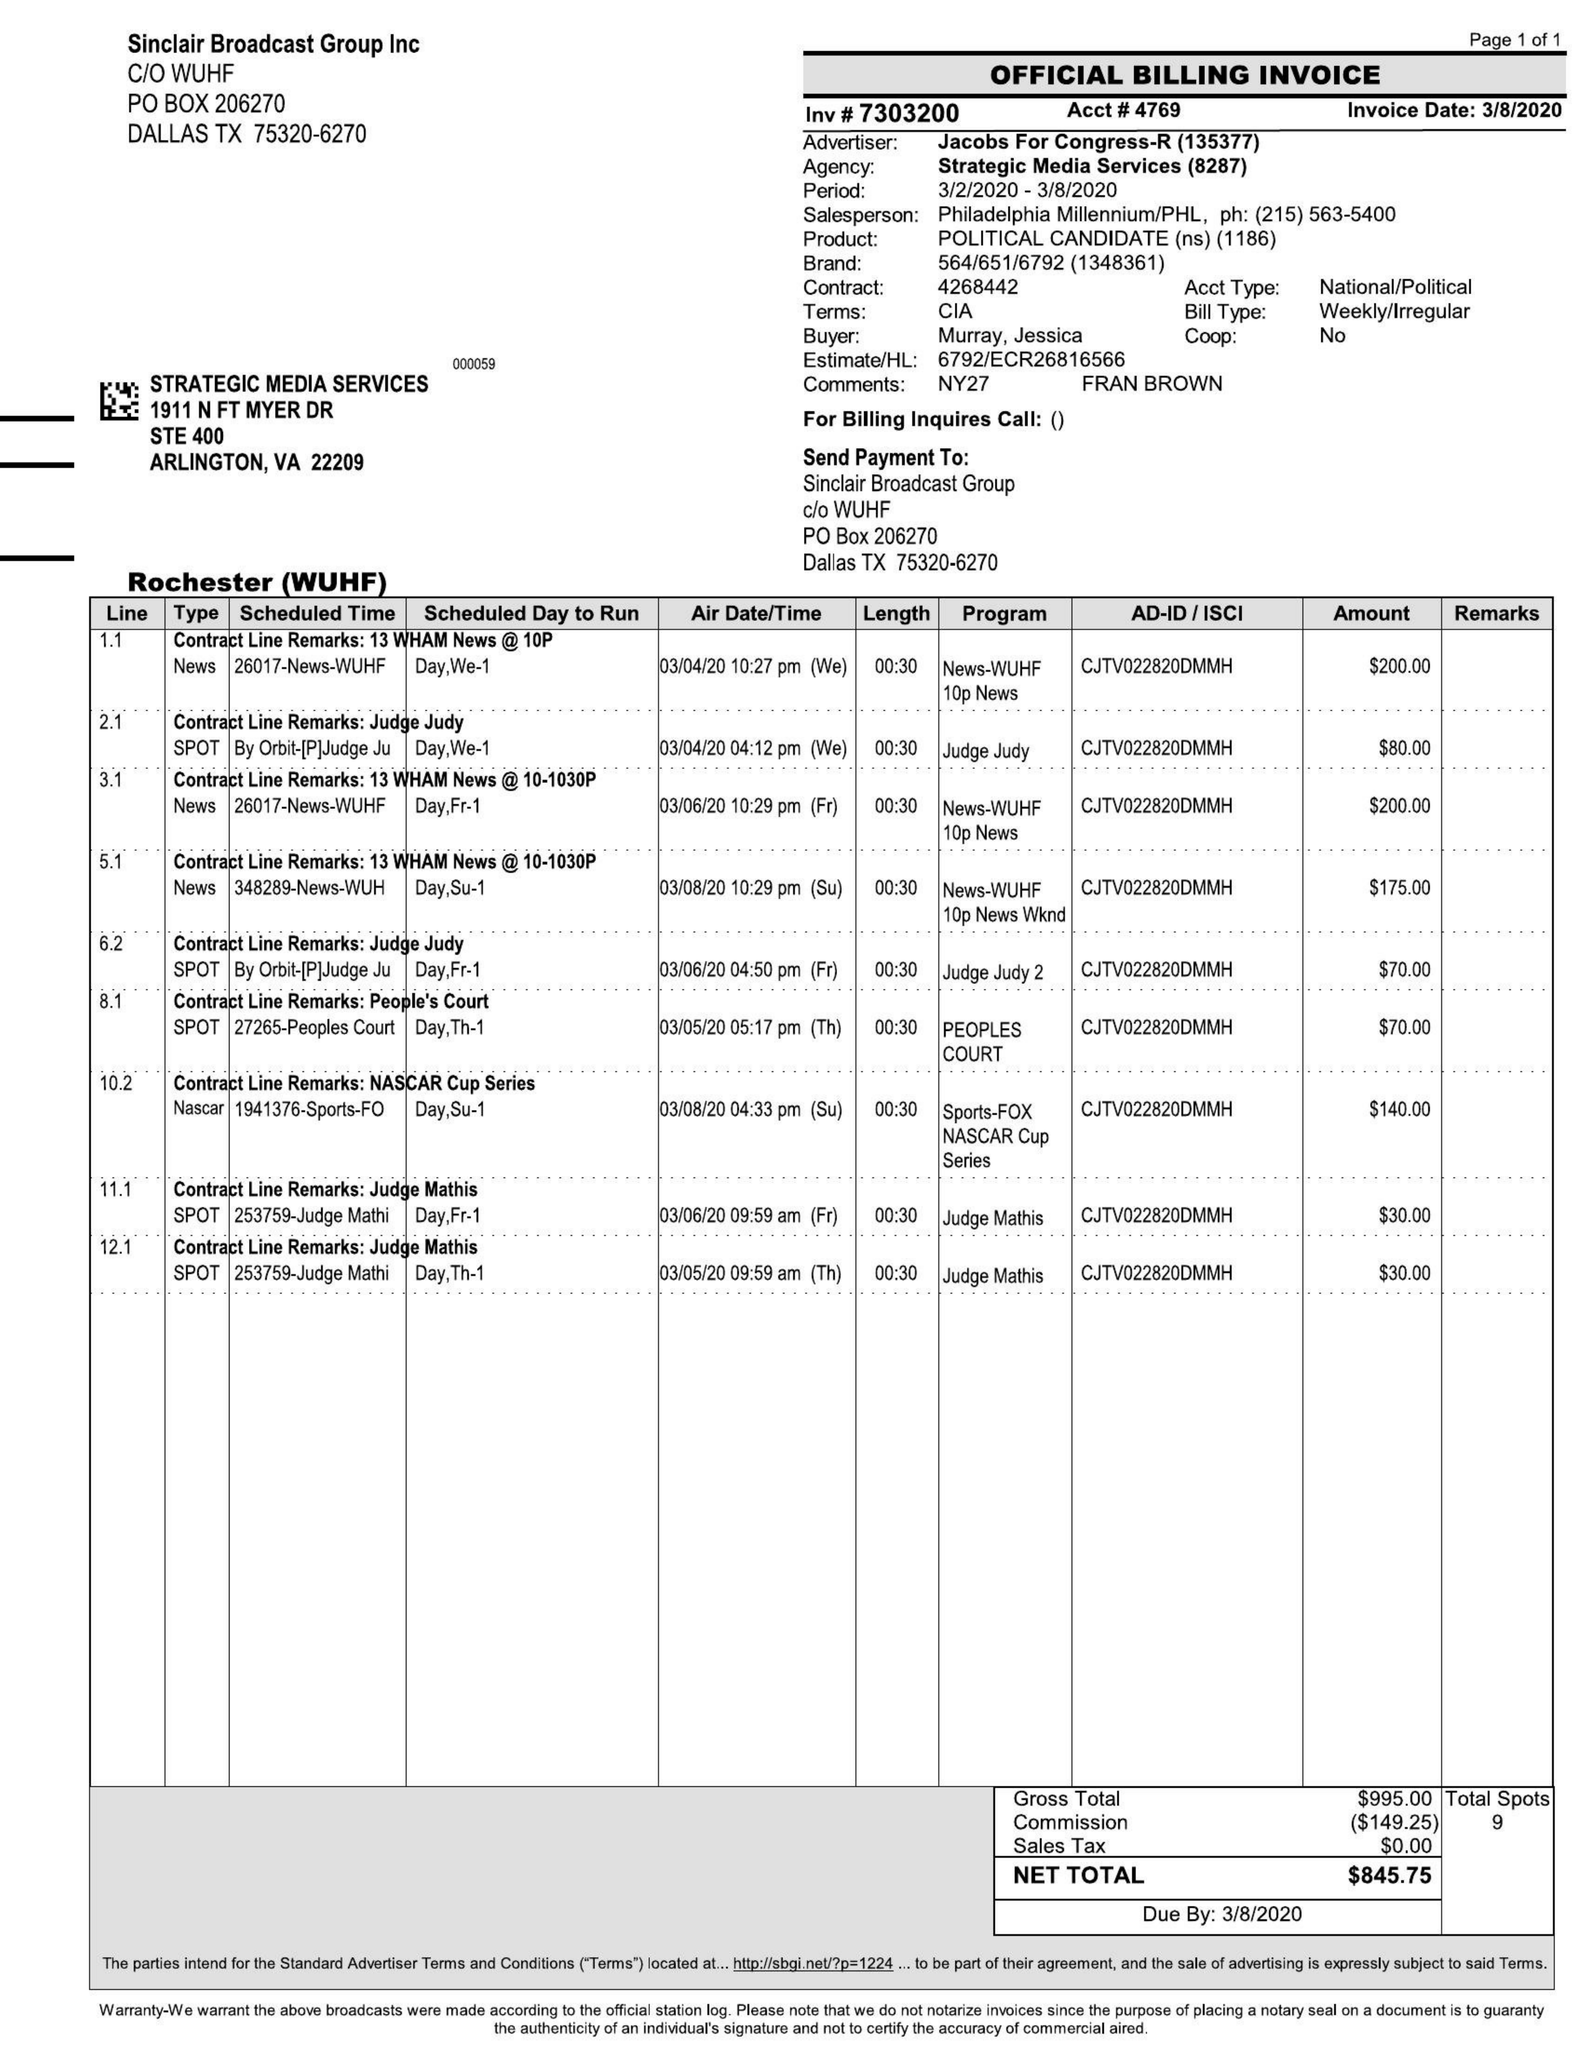What is the value for the flight_to?
Answer the question using a single word or phrase. 03/08/20 